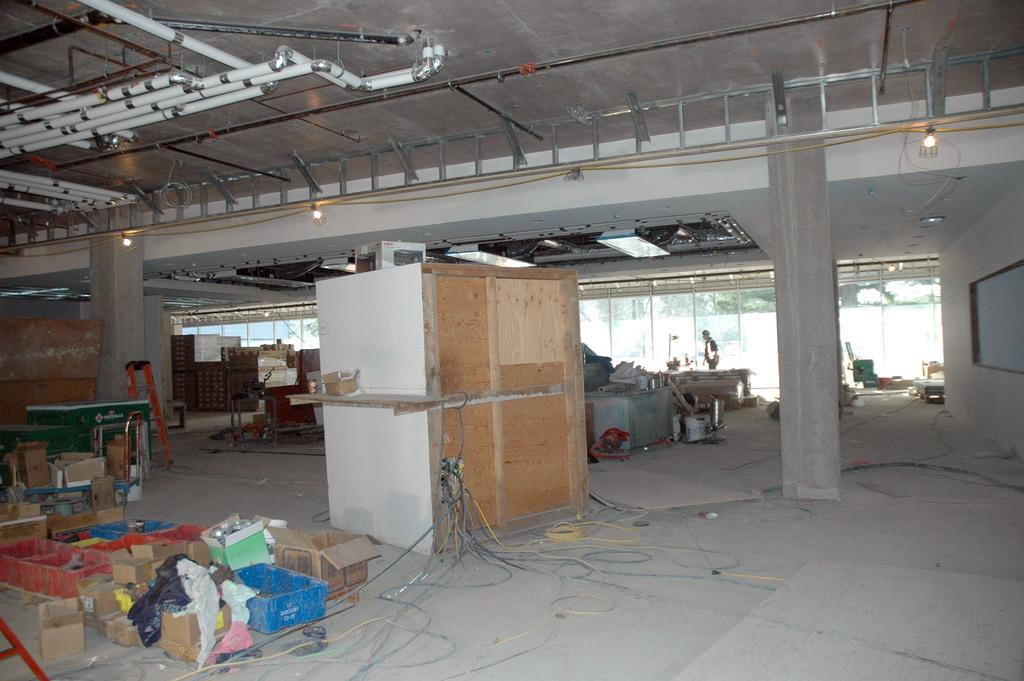What type of boxes can be seen on the floor in the image? There are carton boxes on the floor in the image. What other type of boxes are present in the image? There are wooden boxes in the image. What can be seen on the ceiling in the image? There are lights on the ceiling in the image. Is there a person visible in the image? Yes, a human is standing in the image. What type of plants can be seen growing on the arm of the person in the image? There are no plants visible on the person's arm in the image. What type of crook is present in the image? There is no crook present in the image. 